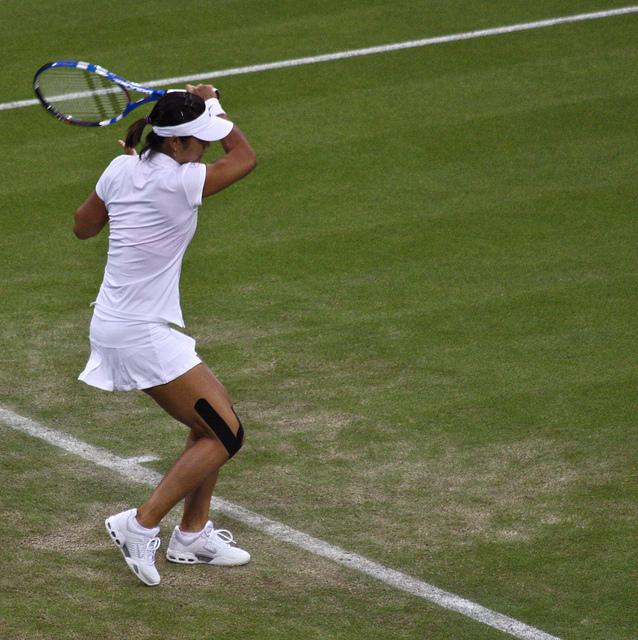What sport is the woman playing?
Concise answer only. Tennis. What color are her tennis racquet strings?
Be succinct. White. What is she swinging?
Concise answer only. Tennis racket. What on her leg?
Concise answer only. Brace. Is the player wearing shorts?
Answer briefly. No. 